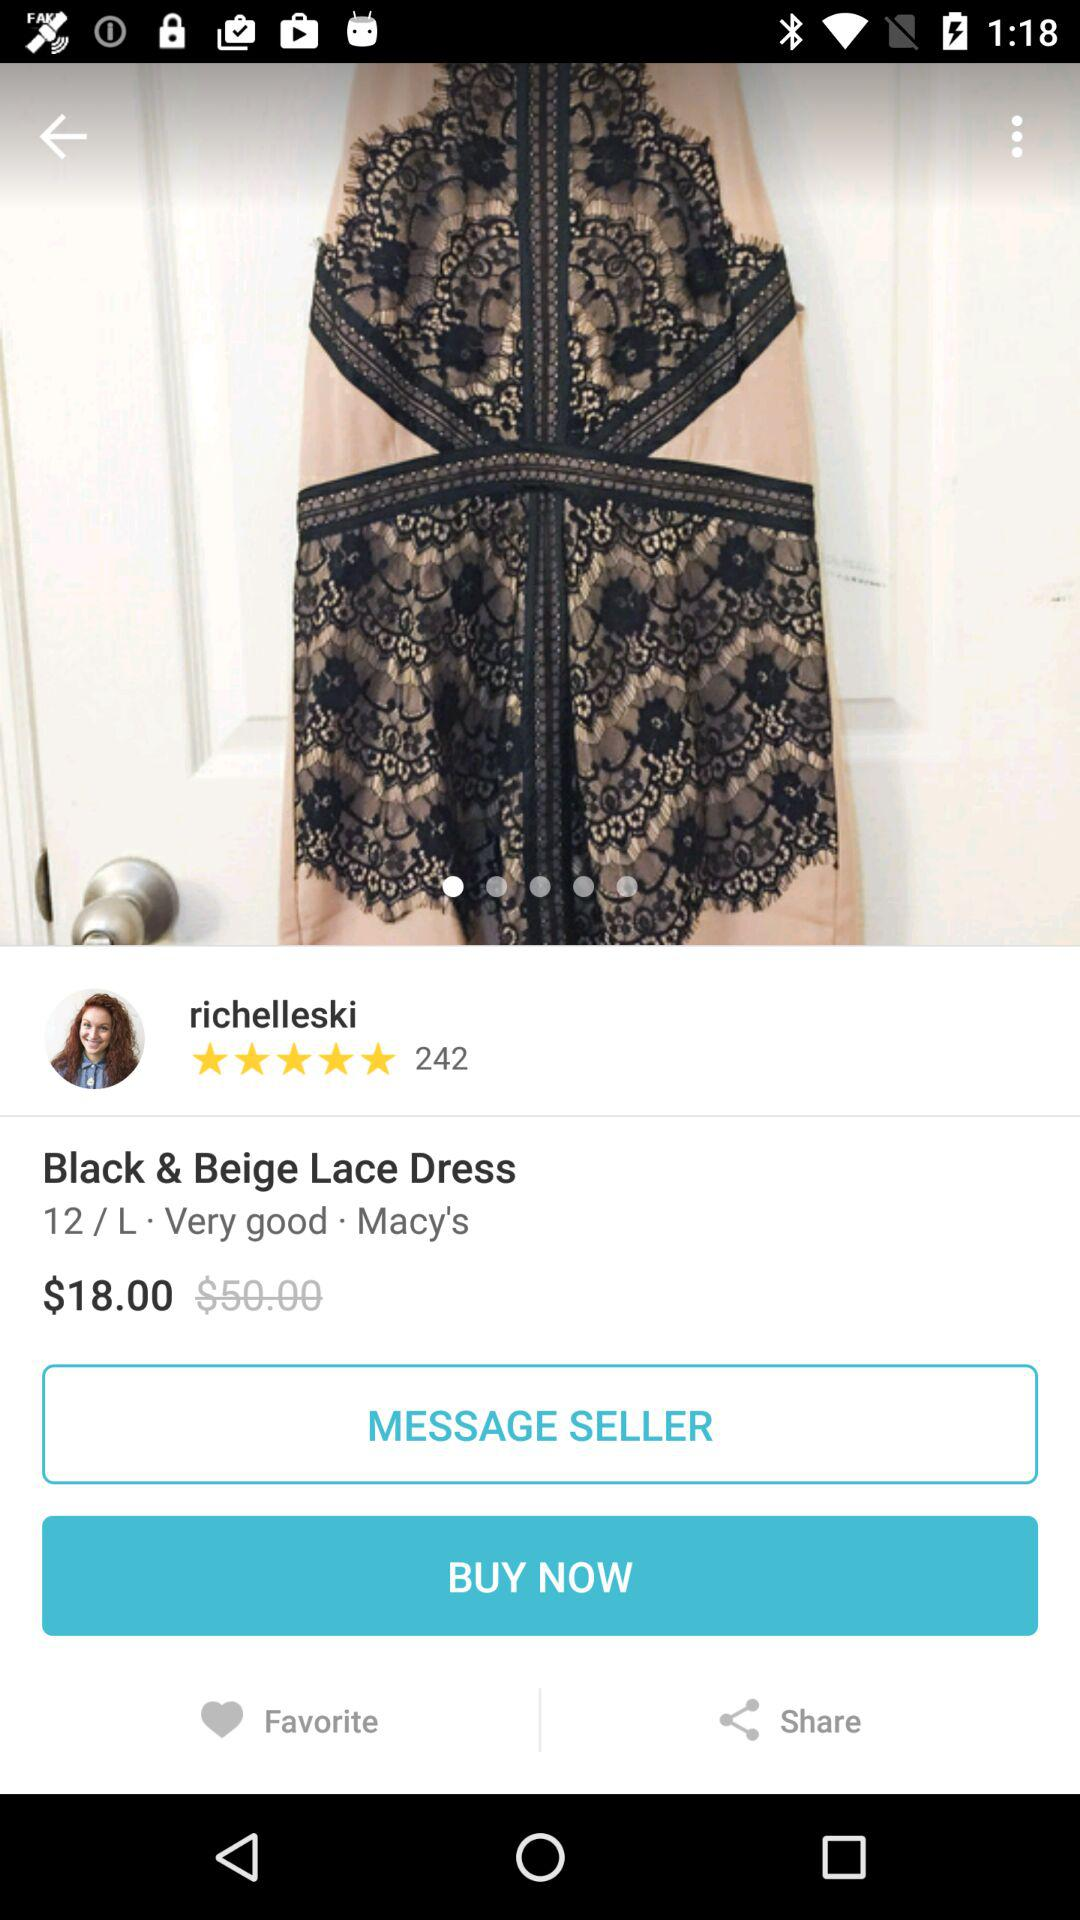What is the actual price of the dress? The actual price of the dress is $50.00. 